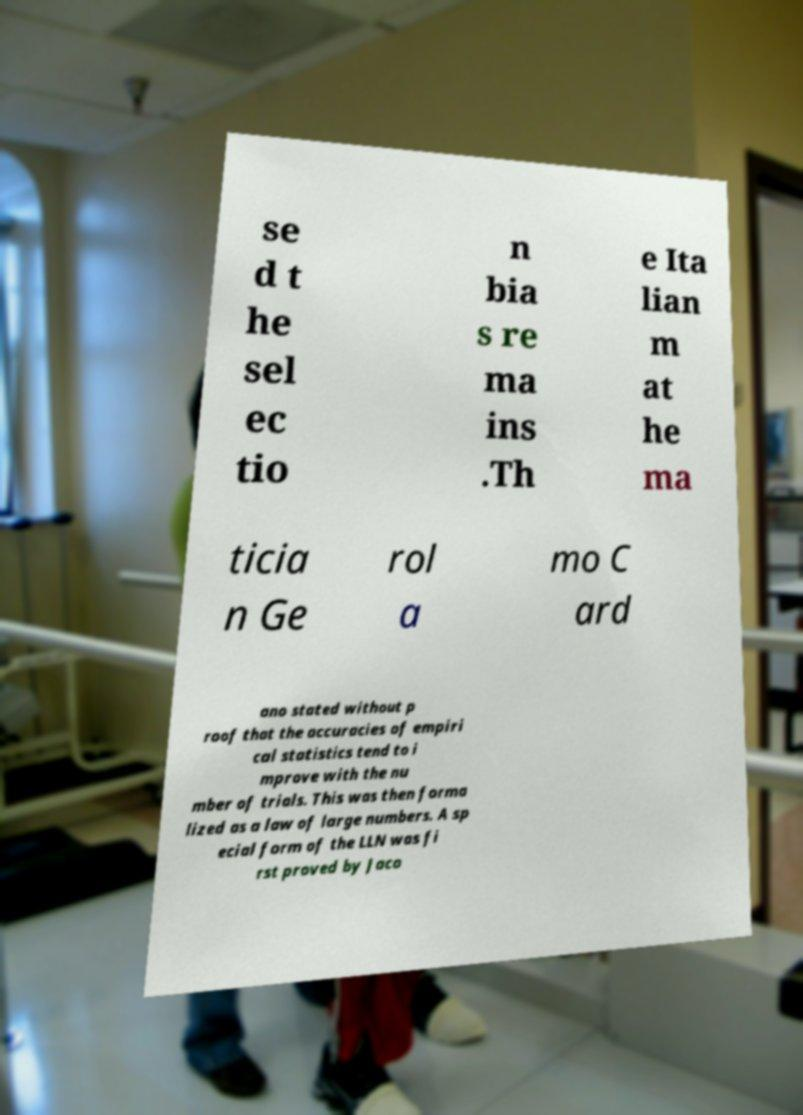There's text embedded in this image that I need extracted. Can you transcribe it verbatim? se d t he sel ec tio n bia s re ma ins .Th e Ita lian m at he ma ticia n Ge rol a mo C ard ano stated without p roof that the accuracies of empiri cal statistics tend to i mprove with the nu mber of trials. This was then forma lized as a law of large numbers. A sp ecial form of the LLN was fi rst proved by Jaco 